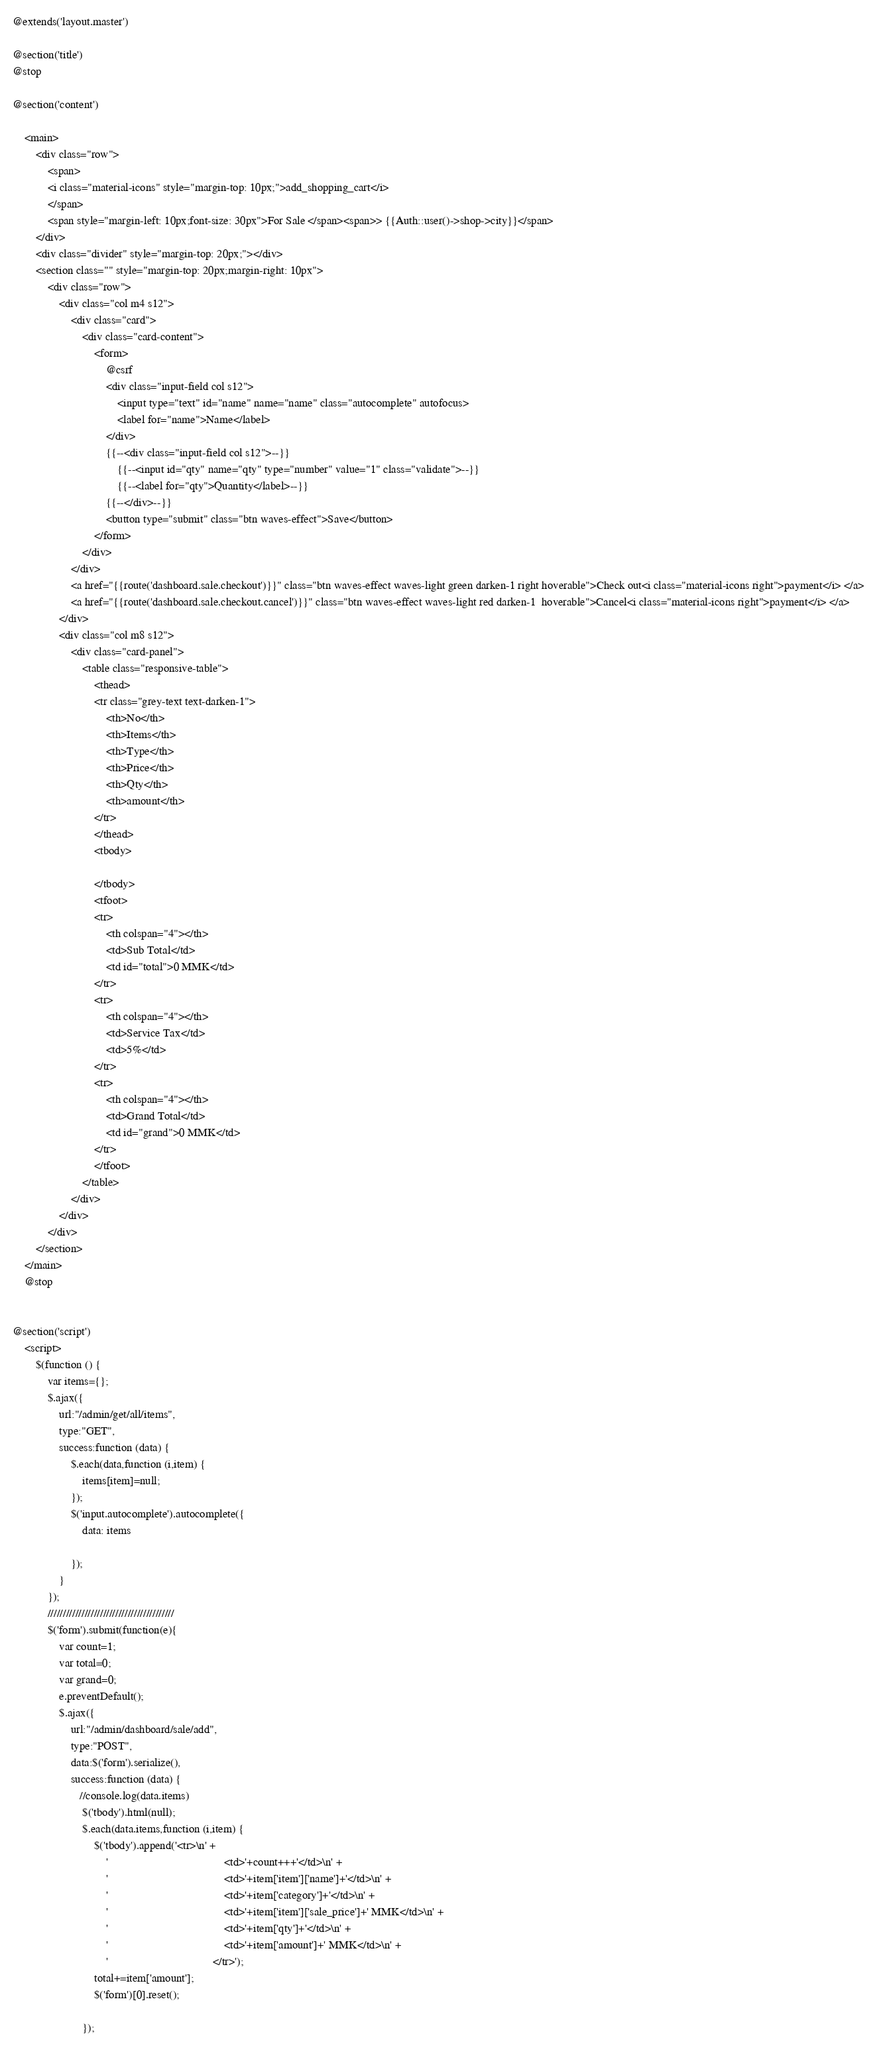Convert code to text. <code><loc_0><loc_0><loc_500><loc_500><_PHP_>@extends('layout.master')

@section('title')
@stop

@section('content')

    <main>
        <div class="row">
            <span>
            <i class="material-icons" style="margin-top: 10px;">add_shopping_cart</i>
            </span>
            <span style="margin-left: 10px;font-size: 30px">For Sale </span><span>> {{Auth::user()->shop->city}}</span>
        </div>
        <div class="divider" style="margin-top: 20px;"></div>
        <section class="" style="margin-top: 20px;margin-right: 10px">
            <div class="row">
                <div class="col m4 s12">
                    <div class="card">
                        <div class="card-content">
                            <form>
                                @csrf
                                <div class="input-field col s12">
                                    <input type="text" id="name" name="name" class="autocomplete" autofocus>
                                    <label for="name">Name</label>
                                </div>
                                {{--<div class="input-field col s12">--}}
                                    {{--<input id="qty" name="qty" type="number" value="1" class="validate">--}}
                                    {{--<label for="qty">Quantity</label>--}}
                                {{--</div>--}}
                                <button type="submit" class="btn waves-effect">Save</button>
                            </form>
                        </div>
                    </div>
                    <a href="{{route('dashboard.sale.checkout')}}" class="btn waves-effect waves-light green darken-1 right hoverable">Check out<i class="material-icons right">payment</i> </a>
                    <a href="{{route('dashboard.sale.checkout.cancel')}}" class="btn waves-effect waves-light red darken-1  hoverable">Cancel<i class="material-icons right">payment</i> </a>
                </div>
                <div class="col m8 s12">
                    <div class="card-panel">
                        <table class="responsive-table">
                            <thead>
                            <tr class="grey-text text-darken-1">
                                <th>No</th>
                                <th>Items</th>
                                <th>Type</th>
                                <th>Price</th>
                                <th>Qty</th>
                                <th>amount</th>
                            </tr>
                            </thead>
                            <tbody>

                            </tbody>
                            <tfoot>
                            <tr>
                                <th colspan="4"></th>
                                <td>Sub Total</td>
                                <td id="total">0 MMK</td>
                            </tr>
                            <tr>
                                <th colspan="4"></th>
                                <td>Service Tax</td>
                                <td>5%</td>
                            </tr>
                            <tr>
                                <th colspan="4"></th>
                                <td>Grand Total</td>
                                <td id="grand">0 MMK</td>
                            </tr>
                            </tfoot>
                        </table>
                    </div>
                </div>
            </div>
        </section>
    </main>
    @stop


@section('script')
    <script>
        $(function () {
            var items={};
            $.ajax({
                url:"/admin/get/all/items",
                type:"GET",
                success:function (data) {
                    $.each(data,function (i,item) {
                        items[item]=null;
                    });
                    $('input.autocomplete').autocomplete({
                        data: items

                    });
                }
            });
            /////////////////////////////////////////
            $('form').submit(function(e){
                var count=1;
                var total=0;
                var grand=0;
                e.preventDefault();
                $.ajax({
                    url:"/admin/dashboard/sale/add",
                    type:"POST",
                    data:$('form').serialize(),
                    success:function (data) {
                       //console.log(data.items)
                        $('tbody').html(null);
                        $.each(data.items,function (i,item) {
                            $('tbody').append('<tr>\n' +
                                '                                        <td>'+count+++'</td>\n' +
                                '                                        <td>'+item['item']['name']+'</td>\n' +
                                '                                        <td>'+item['category']+'</td>\n' +
                                '                                        <td>'+item['item']['sale_price']+' MMK</td>\n' +
                                '                                        <td>'+item['qty']+'</td>\n' +
                                '                                        <td>'+item['amount']+' MMK</td>\n' +
                                '                                    </tr>');
                            total+=item['amount'];
                            $('form')[0].reset();

                        });</code> 